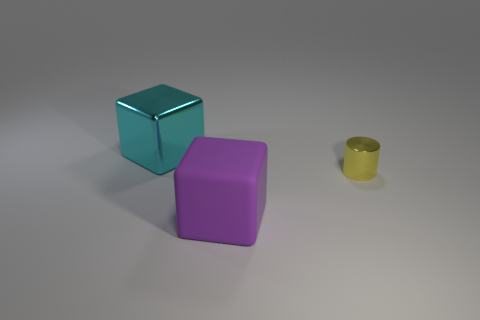There is a thing that is the same material as the tiny cylinder; what color is it?
Give a very brief answer. Cyan. How many small objects are either brown metallic balls or cyan metallic objects?
Offer a terse response. 0. How many yellow metallic things are on the right side of the purple object?
Your answer should be very brief. 1. There is another big object that is the same shape as the large matte object; what is its color?
Ensure brevity in your answer.  Cyan. What number of shiny objects are cubes or yellow cylinders?
Offer a terse response. 2. There is a object that is to the right of the big block in front of the small yellow metal object; are there any metal things that are on the left side of it?
Your response must be concise. Yes. The small metallic cylinder is what color?
Provide a succinct answer. Yellow. Is the shape of the metallic object that is on the left side of the purple rubber object the same as  the purple matte object?
Give a very brief answer. Yes. What number of objects are large purple objects or blocks in front of the yellow metal cylinder?
Ensure brevity in your answer.  1. Does the object behind the small yellow object have the same material as the purple thing?
Offer a terse response. No. 